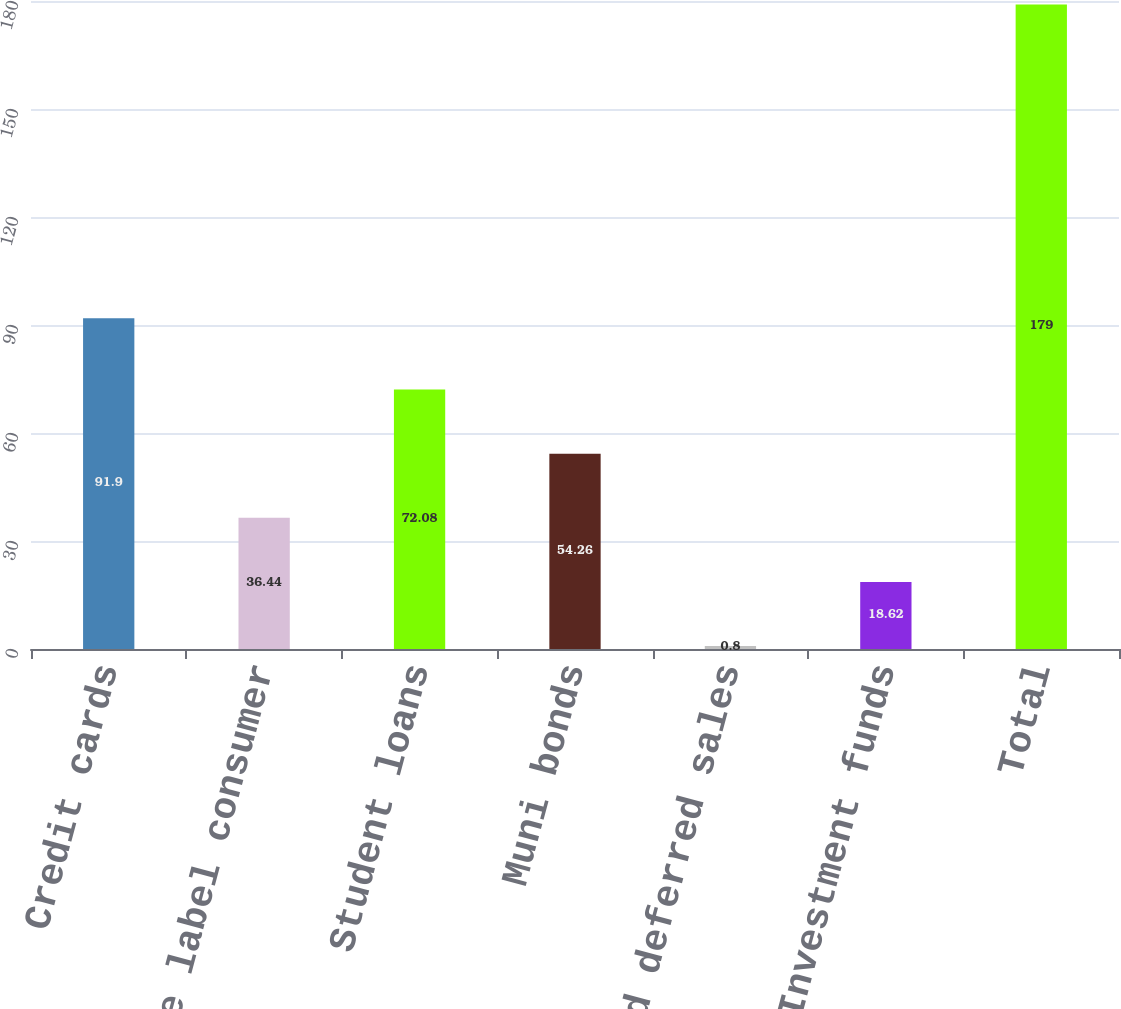Convert chart to OTSL. <chart><loc_0><loc_0><loc_500><loc_500><bar_chart><fcel>Credit cards<fcel>Private label consumer<fcel>Student loans<fcel>Muni bonds<fcel>Mutual fund deferred sales<fcel>Investment funds<fcel>Total<nl><fcel>91.9<fcel>36.44<fcel>72.08<fcel>54.26<fcel>0.8<fcel>18.62<fcel>179<nl></chart> 